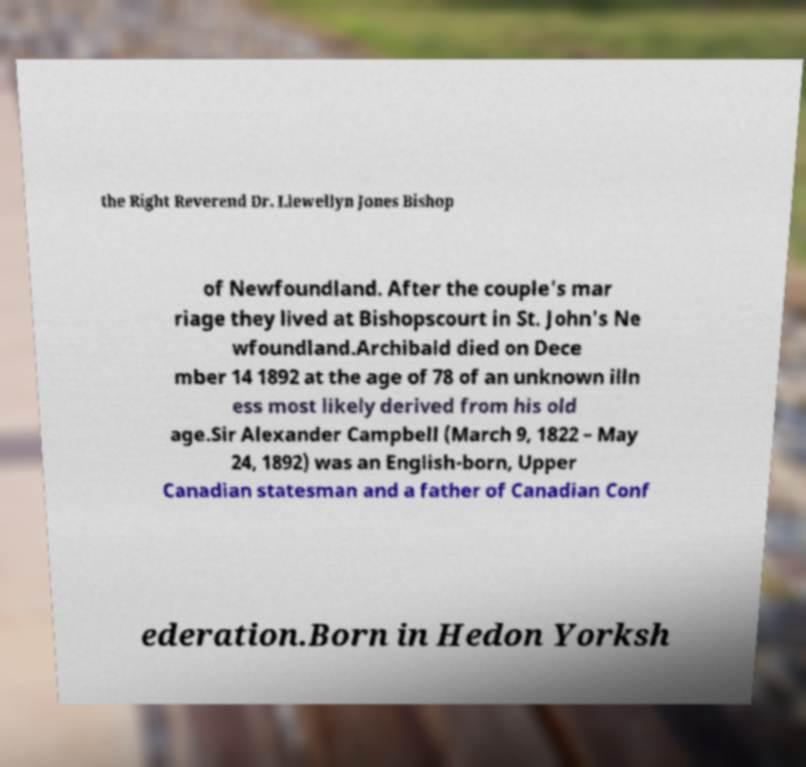Can you read and provide the text displayed in the image?This photo seems to have some interesting text. Can you extract and type it out for me? the Right Reverend Dr. Llewellyn Jones Bishop of Newfoundland. After the couple's mar riage they lived at Bishopscourt in St. John's Ne wfoundland.Archibald died on Dece mber 14 1892 at the age of 78 of an unknown illn ess most likely derived from his old age.Sir Alexander Campbell (March 9, 1822 – May 24, 1892) was an English-born, Upper Canadian statesman and a father of Canadian Conf ederation.Born in Hedon Yorksh 